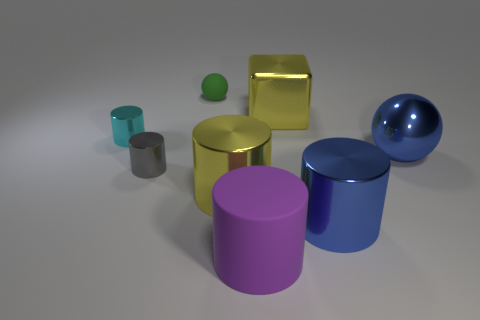Subtract all big cylinders. How many cylinders are left? 2 Add 1 metallic things. How many objects exist? 9 Subtract all gray cylinders. How many cylinders are left? 4 Subtract all blocks. How many objects are left? 7 Subtract all brown cylinders. Subtract all red balls. How many cylinders are left? 5 Add 6 gray metallic cylinders. How many gray metallic cylinders are left? 7 Add 5 small green things. How many small green things exist? 6 Subtract 1 yellow blocks. How many objects are left? 7 Subtract all large purple cylinders. Subtract all tiny green rubber objects. How many objects are left? 6 